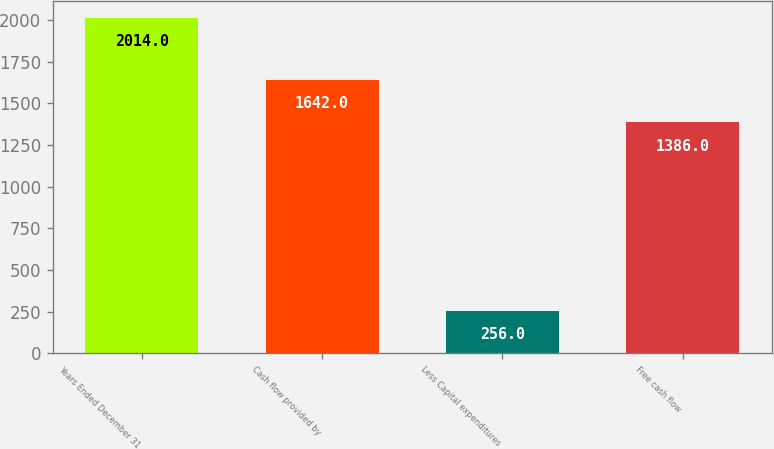Convert chart to OTSL. <chart><loc_0><loc_0><loc_500><loc_500><bar_chart><fcel>Years Ended December 31<fcel>Cash flow provided by<fcel>Less Capital expenditures<fcel>Free cash flow<nl><fcel>2014<fcel>1642<fcel>256<fcel>1386<nl></chart> 